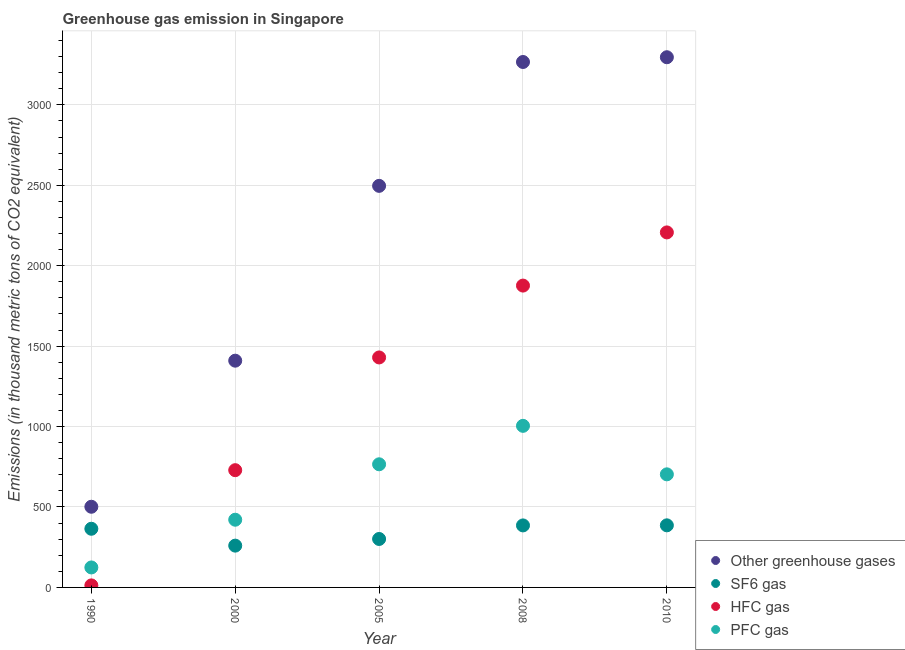How many different coloured dotlines are there?
Provide a short and direct response. 4. What is the emission of pfc gas in 2010?
Provide a succinct answer. 703. Across all years, what is the maximum emission of hfc gas?
Provide a short and direct response. 2207. Across all years, what is the minimum emission of hfc gas?
Provide a short and direct response. 12.6. In which year was the emission of greenhouse gases maximum?
Provide a short and direct response. 2010. What is the total emission of greenhouse gases in the graph?
Offer a very short reply. 1.10e+04. What is the difference between the emission of pfc gas in 1990 and that in 2008?
Your answer should be very brief. -880.3. What is the difference between the emission of sf6 gas in 1990 and the emission of hfc gas in 2008?
Provide a succinct answer. -1511.7. What is the average emission of sf6 gas per year?
Provide a short and direct response. 339.44. In the year 2005, what is the difference between the emission of pfc gas and emission of greenhouse gases?
Your response must be concise. -1730.9. In how many years, is the emission of pfc gas greater than 1300 thousand metric tons?
Offer a terse response. 0. What is the ratio of the emission of greenhouse gases in 1990 to that in 2000?
Keep it short and to the point. 0.36. Is the difference between the emission of greenhouse gases in 1990 and 2008 greater than the difference between the emission of sf6 gas in 1990 and 2008?
Keep it short and to the point. No. What is the difference between the highest and the second highest emission of greenhouse gases?
Provide a succinct answer. 29.6. What is the difference between the highest and the lowest emission of greenhouse gases?
Offer a terse response. 2794.5. Is it the case that in every year, the sum of the emission of hfc gas and emission of pfc gas is greater than the sum of emission of greenhouse gases and emission of sf6 gas?
Offer a very short reply. No. Does the emission of pfc gas monotonically increase over the years?
Make the answer very short. No. How many dotlines are there?
Your answer should be very brief. 4. Does the graph contain any zero values?
Your answer should be compact. No. Does the graph contain grids?
Ensure brevity in your answer.  Yes. How many legend labels are there?
Ensure brevity in your answer.  4. How are the legend labels stacked?
Offer a terse response. Vertical. What is the title of the graph?
Ensure brevity in your answer.  Greenhouse gas emission in Singapore. Does "Industry" appear as one of the legend labels in the graph?
Keep it short and to the point. No. What is the label or title of the Y-axis?
Your response must be concise. Emissions (in thousand metric tons of CO2 equivalent). What is the Emissions (in thousand metric tons of CO2 equivalent) in Other greenhouse gases in 1990?
Provide a short and direct response. 501.5. What is the Emissions (in thousand metric tons of CO2 equivalent) in SF6 gas in 1990?
Offer a very short reply. 364.7. What is the Emissions (in thousand metric tons of CO2 equivalent) in HFC gas in 1990?
Your response must be concise. 12.6. What is the Emissions (in thousand metric tons of CO2 equivalent) in PFC gas in 1990?
Your answer should be very brief. 124.2. What is the Emissions (in thousand metric tons of CO2 equivalent) in Other greenhouse gases in 2000?
Offer a terse response. 1409.6. What is the Emissions (in thousand metric tons of CO2 equivalent) of SF6 gas in 2000?
Keep it short and to the point. 259.8. What is the Emissions (in thousand metric tons of CO2 equivalent) of HFC gas in 2000?
Give a very brief answer. 728.9. What is the Emissions (in thousand metric tons of CO2 equivalent) of PFC gas in 2000?
Give a very brief answer. 420.9. What is the Emissions (in thousand metric tons of CO2 equivalent) of Other greenhouse gases in 2005?
Your response must be concise. 2496.4. What is the Emissions (in thousand metric tons of CO2 equivalent) in SF6 gas in 2005?
Make the answer very short. 301.2. What is the Emissions (in thousand metric tons of CO2 equivalent) of HFC gas in 2005?
Provide a short and direct response. 1429.7. What is the Emissions (in thousand metric tons of CO2 equivalent) of PFC gas in 2005?
Make the answer very short. 765.5. What is the Emissions (in thousand metric tons of CO2 equivalent) in Other greenhouse gases in 2008?
Provide a succinct answer. 3266.4. What is the Emissions (in thousand metric tons of CO2 equivalent) of SF6 gas in 2008?
Offer a very short reply. 385.5. What is the Emissions (in thousand metric tons of CO2 equivalent) in HFC gas in 2008?
Provide a succinct answer. 1876.4. What is the Emissions (in thousand metric tons of CO2 equivalent) in PFC gas in 2008?
Provide a succinct answer. 1004.5. What is the Emissions (in thousand metric tons of CO2 equivalent) of Other greenhouse gases in 2010?
Make the answer very short. 3296. What is the Emissions (in thousand metric tons of CO2 equivalent) in SF6 gas in 2010?
Offer a terse response. 386. What is the Emissions (in thousand metric tons of CO2 equivalent) in HFC gas in 2010?
Provide a succinct answer. 2207. What is the Emissions (in thousand metric tons of CO2 equivalent) of PFC gas in 2010?
Your answer should be compact. 703. Across all years, what is the maximum Emissions (in thousand metric tons of CO2 equivalent) in Other greenhouse gases?
Make the answer very short. 3296. Across all years, what is the maximum Emissions (in thousand metric tons of CO2 equivalent) of SF6 gas?
Provide a succinct answer. 386. Across all years, what is the maximum Emissions (in thousand metric tons of CO2 equivalent) of HFC gas?
Your answer should be compact. 2207. Across all years, what is the maximum Emissions (in thousand metric tons of CO2 equivalent) of PFC gas?
Your answer should be compact. 1004.5. Across all years, what is the minimum Emissions (in thousand metric tons of CO2 equivalent) in Other greenhouse gases?
Your answer should be very brief. 501.5. Across all years, what is the minimum Emissions (in thousand metric tons of CO2 equivalent) in SF6 gas?
Offer a very short reply. 259.8. Across all years, what is the minimum Emissions (in thousand metric tons of CO2 equivalent) in PFC gas?
Your answer should be very brief. 124.2. What is the total Emissions (in thousand metric tons of CO2 equivalent) in Other greenhouse gases in the graph?
Give a very brief answer. 1.10e+04. What is the total Emissions (in thousand metric tons of CO2 equivalent) in SF6 gas in the graph?
Offer a very short reply. 1697.2. What is the total Emissions (in thousand metric tons of CO2 equivalent) in HFC gas in the graph?
Your response must be concise. 6254.6. What is the total Emissions (in thousand metric tons of CO2 equivalent) in PFC gas in the graph?
Give a very brief answer. 3018.1. What is the difference between the Emissions (in thousand metric tons of CO2 equivalent) of Other greenhouse gases in 1990 and that in 2000?
Your answer should be very brief. -908.1. What is the difference between the Emissions (in thousand metric tons of CO2 equivalent) in SF6 gas in 1990 and that in 2000?
Offer a very short reply. 104.9. What is the difference between the Emissions (in thousand metric tons of CO2 equivalent) in HFC gas in 1990 and that in 2000?
Provide a short and direct response. -716.3. What is the difference between the Emissions (in thousand metric tons of CO2 equivalent) of PFC gas in 1990 and that in 2000?
Offer a very short reply. -296.7. What is the difference between the Emissions (in thousand metric tons of CO2 equivalent) in Other greenhouse gases in 1990 and that in 2005?
Offer a very short reply. -1994.9. What is the difference between the Emissions (in thousand metric tons of CO2 equivalent) of SF6 gas in 1990 and that in 2005?
Offer a terse response. 63.5. What is the difference between the Emissions (in thousand metric tons of CO2 equivalent) in HFC gas in 1990 and that in 2005?
Provide a short and direct response. -1417.1. What is the difference between the Emissions (in thousand metric tons of CO2 equivalent) of PFC gas in 1990 and that in 2005?
Ensure brevity in your answer.  -641.3. What is the difference between the Emissions (in thousand metric tons of CO2 equivalent) in Other greenhouse gases in 1990 and that in 2008?
Provide a succinct answer. -2764.9. What is the difference between the Emissions (in thousand metric tons of CO2 equivalent) of SF6 gas in 1990 and that in 2008?
Ensure brevity in your answer.  -20.8. What is the difference between the Emissions (in thousand metric tons of CO2 equivalent) of HFC gas in 1990 and that in 2008?
Your answer should be compact. -1863.8. What is the difference between the Emissions (in thousand metric tons of CO2 equivalent) in PFC gas in 1990 and that in 2008?
Your response must be concise. -880.3. What is the difference between the Emissions (in thousand metric tons of CO2 equivalent) in Other greenhouse gases in 1990 and that in 2010?
Your answer should be compact. -2794.5. What is the difference between the Emissions (in thousand metric tons of CO2 equivalent) of SF6 gas in 1990 and that in 2010?
Make the answer very short. -21.3. What is the difference between the Emissions (in thousand metric tons of CO2 equivalent) of HFC gas in 1990 and that in 2010?
Your response must be concise. -2194.4. What is the difference between the Emissions (in thousand metric tons of CO2 equivalent) of PFC gas in 1990 and that in 2010?
Your response must be concise. -578.8. What is the difference between the Emissions (in thousand metric tons of CO2 equivalent) in Other greenhouse gases in 2000 and that in 2005?
Your response must be concise. -1086.8. What is the difference between the Emissions (in thousand metric tons of CO2 equivalent) of SF6 gas in 2000 and that in 2005?
Provide a succinct answer. -41.4. What is the difference between the Emissions (in thousand metric tons of CO2 equivalent) in HFC gas in 2000 and that in 2005?
Make the answer very short. -700.8. What is the difference between the Emissions (in thousand metric tons of CO2 equivalent) in PFC gas in 2000 and that in 2005?
Keep it short and to the point. -344.6. What is the difference between the Emissions (in thousand metric tons of CO2 equivalent) of Other greenhouse gases in 2000 and that in 2008?
Provide a short and direct response. -1856.8. What is the difference between the Emissions (in thousand metric tons of CO2 equivalent) of SF6 gas in 2000 and that in 2008?
Provide a short and direct response. -125.7. What is the difference between the Emissions (in thousand metric tons of CO2 equivalent) of HFC gas in 2000 and that in 2008?
Your response must be concise. -1147.5. What is the difference between the Emissions (in thousand metric tons of CO2 equivalent) in PFC gas in 2000 and that in 2008?
Your response must be concise. -583.6. What is the difference between the Emissions (in thousand metric tons of CO2 equivalent) of Other greenhouse gases in 2000 and that in 2010?
Ensure brevity in your answer.  -1886.4. What is the difference between the Emissions (in thousand metric tons of CO2 equivalent) in SF6 gas in 2000 and that in 2010?
Make the answer very short. -126.2. What is the difference between the Emissions (in thousand metric tons of CO2 equivalent) of HFC gas in 2000 and that in 2010?
Your answer should be compact. -1478.1. What is the difference between the Emissions (in thousand metric tons of CO2 equivalent) in PFC gas in 2000 and that in 2010?
Offer a very short reply. -282.1. What is the difference between the Emissions (in thousand metric tons of CO2 equivalent) of Other greenhouse gases in 2005 and that in 2008?
Make the answer very short. -770. What is the difference between the Emissions (in thousand metric tons of CO2 equivalent) of SF6 gas in 2005 and that in 2008?
Your answer should be compact. -84.3. What is the difference between the Emissions (in thousand metric tons of CO2 equivalent) of HFC gas in 2005 and that in 2008?
Make the answer very short. -446.7. What is the difference between the Emissions (in thousand metric tons of CO2 equivalent) in PFC gas in 2005 and that in 2008?
Give a very brief answer. -239. What is the difference between the Emissions (in thousand metric tons of CO2 equivalent) of Other greenhouse gases in 2005 and that in 2010?
Offer a terse response. -799.6. What is the difference between the Emissions (in thousand metric tons of CO2 equivalent) in SF6 gas in 2005 and that in 2010?
Your response must be concise. -84.8. What is the difference between the Emissions (in thousand metric tons of CO2 equivalent) of HFC gas in 2005 and that in 2010?
Ensure brevity in your answer.  -777.3. What is the difference between the Emissions (in thousand metric tons of CO2 equivalent) in PFC gas in 2005 and that in 2010?
Your answer should be compact. 62.5. What is the difference between the Emissions (in thousand metric tons of CO2 equivalent) of Other greenhouse gases in 2008 and that in 2010?
Offer a very short reply. -29.6. What is the difference between the Emissions (in thousand metric tons of CO2 equivalent) in HFC gas in 2008 and that in 2010?
Provide a short and direct response. -330.6. What is the difference between the Emissions (in thousand metric tons of CO2 equivalent) of PFC gas in 2008 and that in 2010?
Give a very brief answer. 301.5. What is the difference between the Emissions (in thousand metric tons of CO2 equivalent) in Other greenhouse gases in 1990 and the Emissions (in thousand metric tons of CO2 equivalent) in SF6 gas in 2000?
Give a very brief answer. 241.7. What is the difference between the Emissions (in thousand metric tons of CO2 equivalent) of Other greenhouse gases in 1990 and the Emissions (in thousand metric tons of CO2 equivalent) of HFC gas in 2000?
Offer a terse response. -227.4. What is the difference between the Emissions (in thousand metric tons of CO2 equivalent) of Other greenhouse gases in 1990 and the Emissions (in thousand metric tons of CO2 equivalent) of PFC gas in 2000?
Your answer should be compact. 80.6. What is the difference between the Emissions (in thousand metric tons of CO2 equivalent) in SF6 gas in 1990 and the Emissions (in thousand metric tons of CO2 equivalent) in HFC gas in 2000?
Offer a terse response. -364.2. What is the difference between the Emissions (in thousand metric tons of CO2 equivalent) of SF6 gas in 1990 and the Emissions (in thousand metric tons of CO2 equivalent) of PFC gas in 2000?
Ensure brevity in your answer.  -56.2. What is the difference between the Emissions (in thousand metric tons of CO2 equivalent) in HFC gas in 1990 and the Emissions (in thousand metric tons of CO2 equivalent) in PFC gas in 2000?
Make the answer very short. -408.3. What is the difference between the Emissions (in thousand metric tons of CO2 equivalent) of Other greenhouse gases in 1990 and the Emissions (in thousand metric tons of CO2 equivalent) of SF6 gas in 2005?
Offer a terse response. 200.3. What is the difference between the Emissions (in thousand metric tons of CO2 equivalent) of Other greenhouse gases in 1990 and the Emissions (in thousand metric tons of CO2 equivalent) of HFC gas in 2005?
Keep it short and to the point. -928.2. What is the difference between the Emissions (in thousand metric tons of CO2 equivalent) in Other greenhouse gases in 1990 and the Emissions (in thousand metric tons of CO2 equivalent) in PFC gas in 2005?
Give a very brief answer. -264. What is the difference between the Emissions (in thousand metric tons of CO2 equivalent) in SF6 gas in 1990 and the Emissions (in thousand metric tons of CO2 equivalent) in HFC gas in 2005?
Make the answer very short. -1065. What is the difference between the Emissions (in thousand metric tons of CO2 equivalent) of SF6 gas in 1990 and the Emissions (in thousand metric tons of CO2 equivalent) of PFC gas in 2005?
Keep it short and to the point. -400.8. What is the difference between the Emissions (in thousand metric tons of CO2 equivalent) in HFC gas in 1990 and the Emissions (in thousand metric tons of CO2 equivalent) in PFC gas in 2005?
Offer a very short reply. -752.9. What is the difference between the Emissions (in thousand metric tons of CO2 equivalent) of Other greenhouse gases in 1990 and the Emissions (in thousand metric tons of CO2 equivalent) of SF6 gas in 2008?
Your answer should be compact. 116. What is the difference between the Emissions (in thousand metric tons of CO2 equivalent) in Other greenhouse gases in 1990 and the Emissions (in thousand metric tons of CO2 equivalent) in HFC gas in 2008?
Your answer should be compact. -1374.9. What is the difference between the Emissions (in thousand metric tons of CO2 equivalent) in Other greenhouse gases in 1990 and the Emissions (in thousand metric tons of CO2 equivalent) in PFC gas in 2008?
Offer a terse response. -503. What is the difference between the Emissions (in thousand metric tons of CO2 equivalent) in SF6 gas in 1990 and the Emissions (in thousand metric tons of CO2 equivalent) in HFC gas in 2008?
Your answer should be very brief. -1511.7. What is the difference between the Emissions (in thousand metric tons of CO2 equivalent) of SF6 gas in 1990 and the Emissions (in thousand metric tons of CO2 equivalent) of PFC gas in 2008?
Provide a succinct answer. -639.8. What is the difference between the Emissions (in thousand metric tons of CO2 equivalent) in HFC gas in 1990 and the Emissions (in thousand metric tons of CO2 equivalent) in PFC gas in 2008?
Offer a terse response. -991.9. What is the difference between the Emissions (in thousand metric tons of CO2 equivalent) in Other greenhouse gases in 1990 and the Emissions (in thousand metric tons of CO2 equivalent) in SF6 gas in 2010?
Your answer should be very brief. 115.5. What is the difference between the Emissions (in thousand metric tons of CO2 equivalent) in Other greenhouse gases in 1990 and the Emissions (in thousand metric tons of CO2 equivalent) in HFC gas in 2010?
Give a very brief answer. -1705.5. What is the difference between the Emissions (in thousand metric tons of CO2 equivalent) of Other greenhouse gases in 1990 and the Emissions (in thousand metric tons of CO2 equivalent) of PFC gas in 2010?
Ensure brevity in your answer.  -201.5. What is the difference between the Emissions (in thousand metric tons of CO2 equivalent) of SF6 gas in 1990 and the Emissions (in thousand metric tons of CO2 equivalent) of HFC gas in 2010?
Keep it short and to the point. -1842.3. What is the difference between the Emissions (in thousand metric tons of CO2 equivalent) in SF6 gas in 1990 and the Emissions (in thousand metric tons of CO2 equivalent) in PFC gas in 2010?
Offer a very short reply. -338.3. What is the difference between the Emissions (in thousand metric tons of CO2 equivalent) of HFC gas in 1990 and the Emissions (in thousand metric tons of CO2 equivalent) of PFC gas in 2010?
Your answer should be compact. -690.4. What is the difference between the Emissions (in thousand metric tons of CO2 equivalent) in Other greenhouse gases in 2000 and the Emissions (in thousand metric tons of CO2 equivalent) in SF6 gas in 2005?
Make the answer very short. 1108.4. What is the difference between the Emissions (in thousand metric tons of CO2 equivalent) in Other greenhouse gases in 2000 and the Emissions (in thousand metric tons of CO2 equivalent) in HFC gas in 2005?
Make the answer very short. -20.1. What is the difference between the Emissions (in thousand metric tons of CO2 equivalent) of Other greenhouse gases in 2000 and the Emissions (in thousand metric tons of CO2 equivalent) of PFC gas in 2005?
Make the answer very short. 644.1. What is the difference between the Emissions (in thousand metric tons of CO2 equivalent) in SF6 gas in 2000 and the Emissions (in thousand metric tons of CO2 equivalent) in HFC gas in 2005?
Your response must be concise. -1169.9. What is the difference between the Emissions (in thousand metric tons of CO2 equivalent) in SF6 gas in 2000 and the Emissions (in thousand metric tons of CO2 equivalent) in PFC gas in 2005?
Your response must be concise. -505.7. What is the difference between the Emissions (in thousand metric tons of CO2 equivalent) in HFC gas in 2000 and the Emissions (in thousand metric tons of CO2 equivalent) in PFC gas in 2005?
Make the answer very short. -36.6. What is the difference between the Emissions (in thousand metric tons of CO2 equivalent) in Other greenhouse gases in 2000 and the Emissions (in thousand metric tons of CO2 equivalent) in SF6 gas in 2008?
Keep it short and to the point. 1024.1. What is the difference between the Emissions (in thousand metric tons of CO2 equivalent) of Other greenhouse gases in 2000 and the Emissions (in thousand metric tons of CO2 equivalent) of HFC gas in 2008?
Keep it short and to the point. -466.8. What is the difference between the Emissions (in thousand metric tons of CO2 equivalent) in Other greenhouse gases in 2000 and the Emissions (in thousand metric tons of CO2 equivalent) in PFC gas in 2008?
Provide a succinct answer. 405.1. What is the difference between the Emissions (in thousand metric tons of CO2 equivalent) in SF6 gas in 2000 and the Emissions (in thousand metric tons of CO2 equivalent) in HFC gas in 2008?
Give a very brief answer. -1616.6. What is the difference between the Emissions (in thousand metric tons of CO2 equivalent) of SF6 gas in 2000 and the Emissions (in thousand metric tons of CO2 equivalent) of PFC gas in 2008?
Make the answer very short. -744.7. What is the difference between the Emissions (in thousand metric tons of CO2 equivalent) of HFC gas in 2000 and the Emissions (in thousand metric tons of CO2 equivalent) of PFC gas in 2008?
Keep it short and to the point. -275.6. What is the difference between the Emissions (in thousand metric tons of CO2 equivalent) of Other greenhouse gases in 2000 and the Emissions (in thousand metric tons of CO2 equivalent) of SF6 gas in 2010?
Keep it short and to the point. 1023.6. What is the difference between the Emissions (in thousand metric tons of CO2 equivalent) of Other greenhouse gases in 2000 and the Emissions (in thousand metric tons of CO2 equivalent) of HFC gas in 2010?
Ensure brevity in your answer.  -797.4. What is the difference between the Emissions (in thousand metric tons of CO2 equivalent) of Other greenhouse gases in 2000 and the Emissions (in thousand metric tons of CO2 equivalent) of PFC gas in 2010?
Provide a short and direct response. 706.6. What is the difference between the Emissions (in thousand metric tons of CO2 equivalent) in SF6 gas in 2000 and the Emissions (in thousand metric tons of CO2 equivalent) in HFC gas in 2010?
Offer a terse response. -1947.2. What is the difference between the Emissions (in thousand metric tons of CO2 equivalent) in SF6 gas in 2000 and the Emissions (in thousand metric tons of CO2 equivalent) in PFC gas in 2010?
Your response must be concise. -443.2. What is the difference between the Emissions (in thousand metric tons of CO2 equivalent) in HFC gas in 2000 and the Emissions (in thousand metric tons of CO2 equivalent) in PFC gas in 2010?
Provide a short and direct response. 25.9. What is the difference between the Emissions (in thousand metric tons of CO2 equivalent) in Other greenhouse gases in 2005 and the Emissions (in thousand metric tons of CO2 equivalent) in SF6 gas in 2008?
Provide a succinct answer. 2110.9. What is the difference between the Emissions (in thousand metric tons of CO2 equivalent) of Other greenhouse gases in 2005 and the Emissions (in thousand metric tons of CO2 equivalent) of HFC gas in 2008?
Your response must be concise. 620. What is the difference between the Emissions (in thousand metric tons of CO2 equivalent) in Other greenhouse gases in 2005 and the Emissions (in thousand metric tons of CO2 equivalent) in PFC gas in 2008?
Provide a succinct answer. 1491.9. What is the difference between the Emissions (in thousand metric tons of CO2 equivalent) in SF6 gas in 2005 and the Emissions (in thousand metric tons of CO2 equivalent) in HFC gas in 2008?
Offer a terse response. -1575.2. What is the difference between the Emissions (in thousand metric tons of CO2 equivalent) in SF6 gas in 2005 and the Emissions (in thousand metric tons of CO2 equivalent) in PFC gas in 2008?
Provide a succinct answer. -703.3. What is the difference between the Emissions (in thousand metric tons of CO2 equivalent) in HFC gas in 2005 and the Emissions (in thousand metric tons of CO2 equivalent) in PFC gas in 2008?
Provide a succinct answer. 425.2. What is the difference between the Emissions (in thousand metric tons of CO2 equivalent) in Other greenhouse gases in 2005 and the Emissions (in thousand metric tons of CO2 equivalent) in SF6 gas in 2010?
Provide a short and direct response. 2110.4. What is the difference between the Emissions (in thousand metric tons of CO2 equivalent) of Other greenhouse gases in 2005 and the Emissions (in thousand metric tons of CO2 equivalent) of HFC gas in 2010?
Provide a succinct answer. 289.4. What is the difference between the Emissions (in thousand metric tons of CO2 equivalent) in Other greenhouse gases in 2005 and the Emissions (in thousand metric tons of CO2 equivalent) in PFC gas in 2010?
Keep it short and to the point. 1793.4. What is the difference between the Emissions (in thousand metric tons of CO2 equivalent) of SF6 gas in 2005 and the Emissions (in thousand metric tons of CO2 equivalent) of HFC gas in 2010?
Give a very brief answer. -1905.8. What is the difference between the Emissions (in thousand metric tons of CO2 equivalent) in SF6 gas in 2005 and the Emissions (in thousand metric tons of CO2 equivalent) in PFC gas in 2010?
Your answer should be compact. -401.8. What is the difference between the Emissions (in thousand metric tons of CO2 equivalent) of HFC gas in 2005 and the Emissions (in thousand metric tons of CO2 equivalent) of PFC gas in 2010?
Your answer should be very brief. 726.7. What is the difference between the Emissions (in thousand metric tons of CO2 equivalent) of Other greenhouse gases in 2008 and the Emissions (in thousand metric tons of CO2 equivalent) of SF6 gas in 2010?
Offer a very short reply. 2880.4. What is the difference between the Emissions (in thousand metric tons of CO2 equivalent) in Other greenhouse gases in 2008 and the Emissions (in thousand metric tons of CO2 equivalent) in HFC gas in 2010?
Offer a terse response. 1059.4. What is the difference between the Emissions (in thousand metric tons of CO2 equivalent) in Other greenhouse gases in 2008 and the Emissions (in thousand metric tons of CO2 equivalent) in PFC gas in 2010?
Your response must be concise. 2563.4. What is the difference between the Emissions (in thousand metric tons of CO2 equivalent) of SF6 gas in 2008 and the Emissions (in thousand metric tons of CO2 equivalent) of HFC gas in 2010?
Your answer should be very brief. -1821.5. What is the difference between the Emissions (in thousand metric tons of CO2 equivalent) of SF6 gas in 2008 and the Emissions (in thousand metric tons of CO2 equivalent) of PFC gas in 2010?
Offer a terse response. -317.5. What is the difference between the Emissions (in thousand metric tons of CO2 equivalent) in HFC gas in 2008 and the Emissions (in thousand metric tons of CO2 equivalent) in PFC gas in 2010?
Provide a short and direct response. 1173.4. What is the average Emissions (in thousand metric tons of CO2 equivalent) of Other greenhouse gases per year?
Ensure brevity in your answer.  2193.98. What is the average Emissions (in thousand metric tons of CO2 equivalent) of SF6 gas per year?
Ensure brevity in your answer.  339.44. What is the average Emissions (in thousand metric tons of CO2 equivalent) in HFC gas per year?
Make the answer very short. 1250.92. What is the average Emissions (in thousand metric tons of CO2 equivalent) of PFC gas per year?
Your response must be concise. 603.62. In the year 1990, what is the difference between the Emissions (in thousand metric tons of CO2 equivalent) of Other greenhouse gases and Emissions (in thousand metric tons of CO2 equivalent) of SF6 gas?
Your answer should be compact. 136.8. In the year 1990, what is the difference between the Emissions (in thousand metric tons of CO2 equivalent) of Other greenhouse gases and Emissions (in thousand metric tons of CO2 equivalent) of HFC gas?
Provide a succinct answer. 488.9. In the year 1990, what is the difference between the Emissions (in thousand metric tons of CO2 equivalent) of Other greenhouse gases and Emissions (in thousand metric tons of CO2 equivalent) of PFC gas?
Ensure brevity in your answer.  377.3. In the year 1990, what is the difference between the Emissions (in thousand metric tons of CO2 equivalent) of SF6 gas and Emissions (in thousand metric tons of CO2 equivalent) of HFC gas?
Make the answer very short. 352.1. In the year 1990, what is the difference between the Emissions (in thousand metric tons of CO2 equivalent) in SF6 gas and Emissions (in thousand metric tons of CO2 equivalent) in PFC gas?
Your answer should be compact. 240.5. In the year 1990, what is the difference between the Emissions (in thousand metric tons of CO2 equivalent) in HFC gas and Emissions (in thousand metric tons of CO2 equivalent) in PFC gas?
Offer a terse response. -111.6. In the year 2000, what is the difference between the Emissions (in thousand metric tons of CO2 equivalent) in Other greenhouse gases and Emissions (in thousand metric tons of CO2 equivalent) in SF6 gas?
Your answer should be very brief. 1149.8. In the year 2000, what is the difference between the Emissions (in thousand metric tons of CO2 equivalent) in Other greenhouse gases and Emissions (in thousand metric tons of CO2 equivalent) in HFC gas?
Offer a very short reply. 680.7. In the year 2000, what is the difference between the Emissions (in thousand metric tons of CO2 equivalent) in Other greenhouse gases and Emissions (in thousand metric tons of CO2 equivalent) in PFC gas?
Your response must be concise. 988.7. In the year 2000, what is the difference between the Emissions (in thousand metric tons of CO2 equivalent) of SF6 gas and Emissions (in thousand metric tons of CO2 equivalent) of HFC gas?
Make the answer very short. -469.1. In the year 2000, what is the difference between the Emissions (in thousand metric tons of CO2 equivalent) of SF6 gas and Emissions (in thousand metric tons of CO2 equivalent) of PFC gas?
Give a very brief answer. -161.1. In the year 2000, what is the difference between the Emissions (in thousand metric tons of CO2 equivalent) in HFC gas and Emissions (in thousand metric tons of CO2 equivalent) in PFC gas?
Provide a succinct answer. 308. In the year 2005, what is the difference between the Emissions (in thousand metric tons of CO2 equivalent) in Other greenhouse gases and Emissions (in thousand metric tons of CO2 equivalent) in SF6 gas?
Give a very brief answer. 2195.2. In the year 2005, what is the difference between the Emissions (in thousand metric tons of CO2 equivalent) of Other greenhouse gases and Emissions (in thousand metric tons of CO2 equivalent) of HFC gas?
Your answer should be very brief. 1066.7. In the year 2005, what is the difference between the Emissions (in thousand metric tons of CO2 equivalent) in Other greenhouse gases and Emissions (in thousand metric tons of CO2 equivalent) in PFC gas?
Ensure brevity in your answer.  1730.9. In the year 2005, what is the difference between the Emissions (in thousand metric tons of CO2 equivalent) in SF6 gas and Emissions (in thousand metric tons of CO2 equivalent) in HFC gas?
Ensure brevity in your answer.  -1128.5. In the year 2005, what is the difference between the Emissions (in thousand metric tons of CO2 equivalent) in SF6 gas and Emissions (in thousand metric tons of CO2 equivalent) in PFC gas?
Provide a short and direct response. -464.3. In the year 2005, what is the difference between the Emissions (in thousand metric tons of CO2 equivalent) in HFC gas and Emissions (in thousand metric tons of CO2 equivalent) in PFC gas?
Your response must be concise. 664.2. In the year 2008, what is the difference between the Emissions (in thousand metric tons of CO2 equivalent) in Other greenhouse gases and Emissions (in thousand metric tons of CO2 equivalent) in SF6 gas?
Your answer should be very brief. 2880.9. In the year 2008, what is the difference between the Emissions (in thousand metric tons of CO2 equivalent) in Other greenhouse gases and Emissions (in thousand metric tons of CO2 equivalent) in HFC gas?
Provide a succinct answer. 1390. In the year 2008, what is the difference between the Emissions (in thousand metric tons of CO2 equivalent) of Other greenhouse gases and Emissions (in thousand metric tons of CO2 equivalent) of PFC gas?
Offer a terse response. 2261.9. In the year 2008, what is the difference between the Emissions (in thousand metric tons of CO2 equivalent) of SF6 gas and Emissions (in thousand metric tons of CO2 equivalent) of HFC gas?
Offer a terse response. -1490.9. In the year 2008, what is the difference between the Emissions (in thousand metric tons of CO2 equivalent) of SF6 gas and Emissions (in thousand metric tons of CO2 equivalent) of PFC gas?
Give a very brief answer. -619. In the year 2008, what is the difference between the Emissions (in thousand metric tons of CO2 equivalent) in HFC gas and Emissions (in thousand metric tons of CO2 equivalent) in PFC gas?
Keep it short and to the point. 871.9. In the year 2010, what is the difference between the Emissions (in thousand metric tons of CO2 equivalent) of Other greenhouse gases and Emissions (in thousand metric tons of CO2 equivalent) of SF6 gas?
Give a very brief answer. 2910. In the year 2010, what is the difference between the Emissions (in thousand metric tons of CO2 equivalent) of Other greenhouse gases and Emissions (in thousand metric tons of CO2 equivalent) of HFC gas?
Your answer should be compact. 1089. In the year 2010, what is the difference between the Emissions (in thousand metric tons of CO2 equivalent) in Other greenhouse gases and Emissions (in thousand metric tons of CO2 equivalent) in PFC gas?
Your answer should be compact. 2593. In the year 2010, what is the difference between the Emissions (in thousand metric tons of CO2 equivalent) in SF6 gas and Emissions (in thousand metric tons of CO2 equivalent) in HFC gas?
Keep it short and to the point. -1821. In the year 2010, what is the difference between the Emissions (in thousand metric tons of CO2 equivalent) in SF6 gas and Emissions (in thousand metric tons of CO2 equivalent) in PFC gas?
Your answer should be compact. -317. In the year 2010, what is the difference between the Emissions (in thousand metric tons of CO2 equivalent) of HFC gas and Emissions (in thousand metric tons of CO2 equivalent) of PFC gas?
Provide a succinct answer. 1504. What is the ratio of the Emissions (in thousand metric tons of CO2 equivalent) in Other greenhouse gases in 1990 to that in 2000?
Offer a very short reply. 0.36. What is the ratio of the Emissions (in thousand metric tons of CO2 equivalent) in SF6 gas in 1990 to that in 2000?
Offer a terse response. 1.4. What is the ratio of the Emissions (in thousand metric tons of CO2 equivalent) of HFC gas in 1990 to that in 2000?
Provide a succinct answer. 0.02. What is the ratio of the Emissions (in thousand metric tons of CO2 equivalent) in PFC gas in 1990 to that in 2000?
Provide a short and direct response. 0.3. What is the ratio of the Emissions (in thousand metric tons of CO2 equivalent) in Other greenhouse gases in 1990 to that in 2005?
Keep it short and to the point. 0.2. What is the ratio of the Emissions (in thousand metric tons of CO2 equivalent) of SF6 gas in 1990 to that in 2005?
Your answer should be compact. 1.21. What is the ratio of the Emissions (in thousand metric tons of CO2 equivalent) in HFC gas in 1990 to that in 2005?
Keep it short and to the point. 0.01. What is the ratio of the Emissions (in thousand metric tons of CO2 equivalent) of PFC gas in 1990 to that in 2005?
Your answer should be very brief. 0.16. What is the ratio of the Emissions (in thousand metric tons of CO2 equivalent) of Other greenhouse gases in 1990 to that in 2008?
Keep it short and to the point. 0.15. What is the ratio of the Emissions (in thousand metric tons of CO2 equivalent) of SF6 gas in 1990 to that in 2008?
Offer a very short reply. 0.95. What is the ratio of the Emissions (in thousand metric tons of CO2 equivalent) in HFC gas in 1990 to that in 2008?
Offer a very short reply. 0.01. What is the ratio of the Emissions (in thousand metric tons of CO2 equivalent) of PFC gas in 1990 to that in 2008?
Keep it short and to the point. 0.12. What is the ratio of the Emissions (in thousand metric tons of CO2 equivalent) in Other greenhouse gases in 1990 to that in 2010?
Provide a succinct answer. 0.15. What is the ratio of the Emissions (in thousand metric tons of CO2 equivalent) in SF6 gas in 1990 to that in 2010?
Your response must be concise. 0.94. What is the ratio of the Emissions (in thousand metric tons of CO2 equivalent) in HFC gas in 1990 to that in 2010?
Your response must be concise. 0.01. What is the ratio of the Emissions (in thousand metric tons of CO2 equivalent) in PFC gas in 1990 to that in 2010?
Give a very brief answer. 0.18. What is the ratio of the Emissions (in thousand metric tons of CO2 equivalent) in Other greenhouse gases in 2000 to that in 2005?
Offer a very short reply. 0.56. What is the ratio of the Emissions (in thousand metric tons of CO2 equivalent) in SF6 gas in 2000 to that in 2005?
Your answer should be very brief. 0.86. What is the ratio of the Emissions (in thousand metric tons of CO2 equivalent) in HFC gas in 2000 to that in 2005?
Provide a short and direct response. 0.51. What is the ratio of the Emissions (in thousand metric tons of CO2 equivalent) in PFC gas in 2000 to that in 2005?
Your answer should be very brief. 0.55. What is the ratio of the Emissions (in thousand metric tons of CO2 equivalent) in Other greenhouse gases in 2000 to that in 2008?
Your answer should be very brief. 0.43. What is the ratio of the Emissions (in thousand metric tons of CO2 equivalent) of SF6 gas in 2000 to that in 2008?
Offer a very short reply. 0.67. What is the ratio of the Emissions (in thousand metric tons of CO2 equivalent) of HFC gas in 2000 to that in 2008?
Ensure brevity in your answer.  0.39. What is the ratio of the Emissions (in thousand metric tons of CO2 equivalent) in PFC gas in 2000 to that in 2008?
Give a very brief answer. 0.42. What is the ratio of the Emissions (in thousand metric tons of CO2 equivalent) in Other greenhouse gases in 2000 to that in 2010?
Provide a short and direct response. 0.43. What is the ratio of the Emissions (in thousand metric tons of CO2 equivalent) of SF6 gas in 2000 to that in 2010?
Provide a succinct answer. 0.67. What is the ratio of the Emissions (in thousand metric tons of CO2 equivalent) in HFC gas in 2000 to that in 2010?
Offer a very short reply. 0.33. What is the ratio of the Emissions (in thousand metric tons of CO2 equivalent) in PFC gas in 2000 to that in 2010?
Your answer should be compact. 0.6. What is the ratio of the Emissions (in thousand metric tons of CO2 equivalent) in Other greenhouse gases in 2005 to that in 2008?
Offer a very short reply. 0.76. What is the ratio of the Emissions (in thousand metric tons of CO2 equivalent) of SF6 gas in 2005 to that in 2008?
Keep it short and to the point. 0.78. What is the ratio of the Emissions (in thousand metric tons of CO2 equivalent) of HFC gas in 2005 to that in 2008?
Keep it short and to the point. 0.76. What is the ratio of the Emissions (in thousand metric tons of CO2 equivalent) of PFC gas in 2005 to that in 2008?
Make the answer very short. 0.76. What is the ratio of the Emissions (in thousand metric tons of CO2 equivalent) of Other greenhouse gases in 2005 to that in 2010?
Provide a succinct answer. 0.76. What is the ratio of the Emissions (in thousand metric tons of CO2 equivalent) of SF6 gas in 2005 to that in 2010?
Keep it short and to the point. 0.78. What is the ratio of the Emissions (in thousand metric tons of CO2 equivalent) of HFC gas in 2005 to that in 2010?
Give a very brief answer. 0.65. What is the ratio of the Emissions (in thousand metric tons of CO2 equivalent) in PFC gas in 2005 to that in 2010?
Give a very brief answer. 1.09. What is the ratio of the Emissions (in thousand metric tons of CO2 equivalent) in HFC gas in 2008 to that in 2010?
Offer a very short reply. 0.85. What is the ratio of the Emissions (in thousand metric tons of CO2 equivalent) of PFC gas in 2008 to that in 2010?
Make the answer very short. 1.43. What is the difference between the highest and the second highest Emissions (in thousand metric tons of CO2 equivalent) of Other greenhouse gases?
Your answer should be compact. 29.6. What is the difference between the highest and the second highest Emissions (in thousand metric tons of CO2 equivalent) in SF6 gas?
Offer a very short reply. 0.5. What is the difference between the highest and the second highest Emissions (in thousand metric tons of CO2 equivalent) of HFC gas?
Make the answer very short. 330.6. What is the difference between the highest and the second highest Emissions (in thousand metric tons of CO2 equivalent) in PFC gas?
Offer a very short reply. 239. What is the difference between the highest and the lowest Emissions (in thousand metric tons of CO2 equivalent) in Other greenhouse gases?
Offer a terse response. 2794.5. What is the difference between the highest and the lowest Emissions (in thousand metric tons of CO2 equivalent) of SF6 gas?
Keep it short and to the point. 126.2. What is the difference between the highest and the lowest Emissions (in thousand metric tons of CO2 equivalent) of HFC gas?
Your answer should be very brief. 2194.4. What is the difference between the highest and the lowest Emissions (in thousand metric tons of CO2 equivalent) of PFC gas?
Keep it short and to the point. 880.3. 